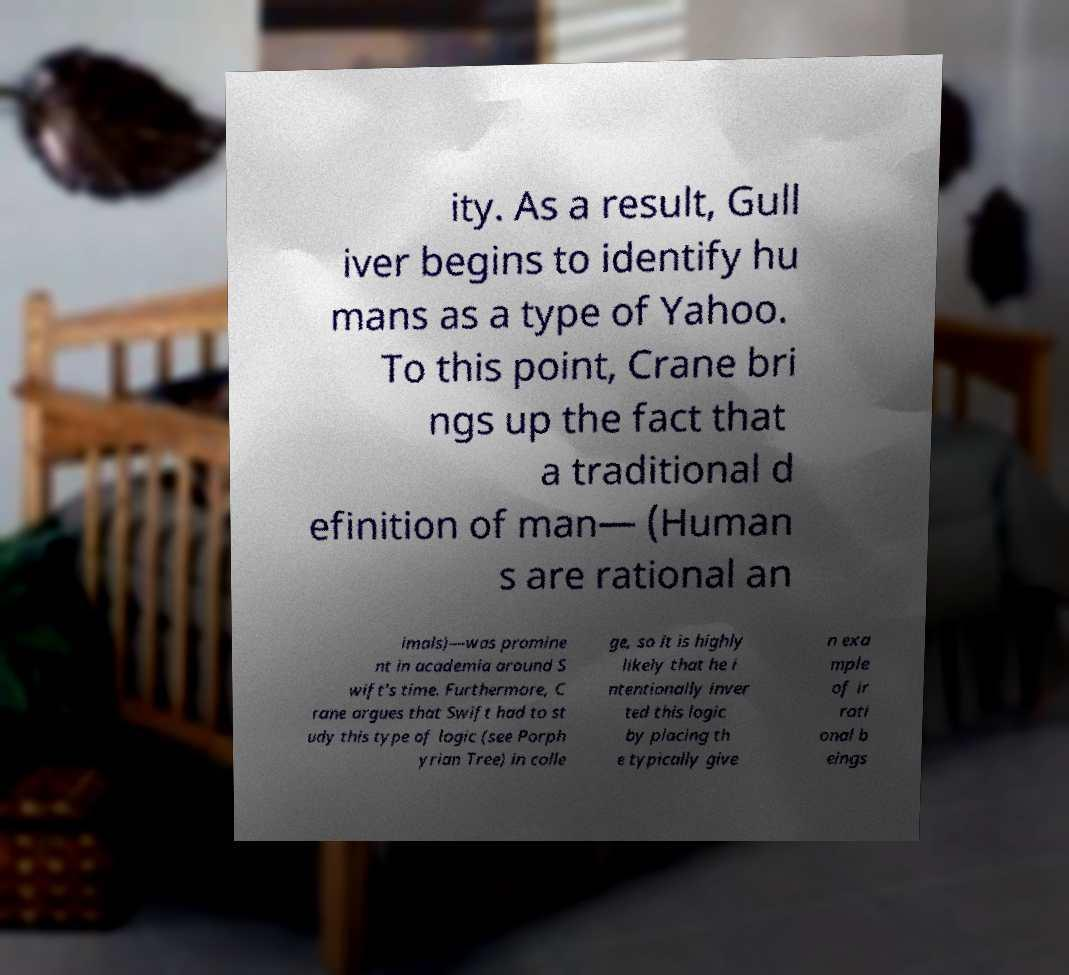Can you accurately transcribe the text from the provided image for me? ity. As a result, Gull iver begins to identify hu mans as a type of Yahoo. To this point, Crane bri ngs up the fact that a traditional d efinition of man— (Human s are rational an imals)—was promine nt in academia around S wift's time. Furthermore, C rane argues that Swift had to st udy this type of logic (see Porph yrian Tree) in colle ge, so it is highly likely that he i ntentionally inver ted this logic by placing th e typically give n exa mple of ir rati onal b eings 